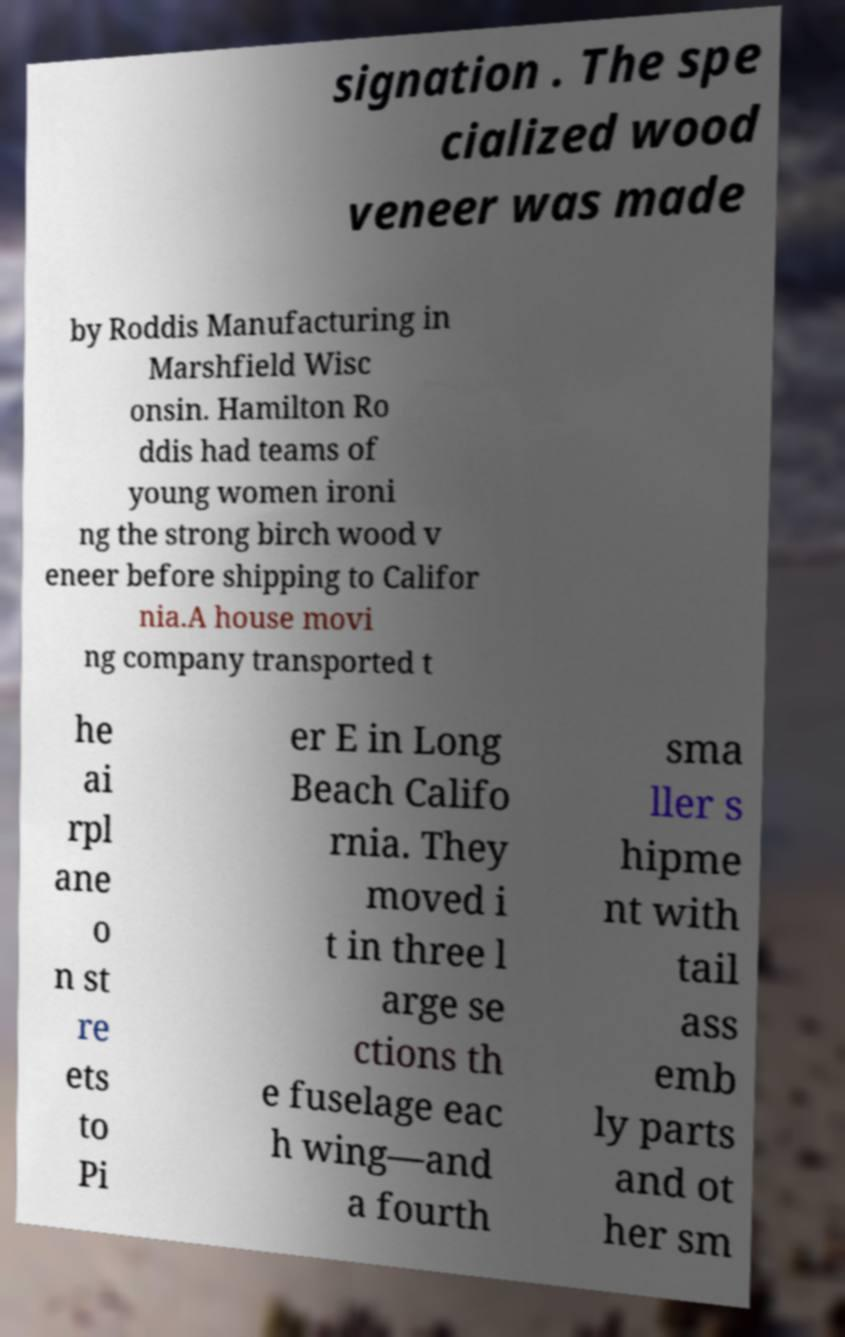For documentation purposes, I need the text within this image transcribed. Could you provide that? signation . The spe cialized wood veneer was made by Roddis Manufacturing in Marshfield Wisc onsin. Hamilton Ro ddis had teams of young women ironi ng the strong birch wood v eneer before shipping to Califor nia.A house movi ng company transported t he ai rpl ane o n st re ets to Pi er E in Long Beach Califo rnia. They moved i t in three l arge se ctions th e fuselage eac h wing—and a fourth sma ller s hipme nt with tail ass emb ly parts and ot her sm 